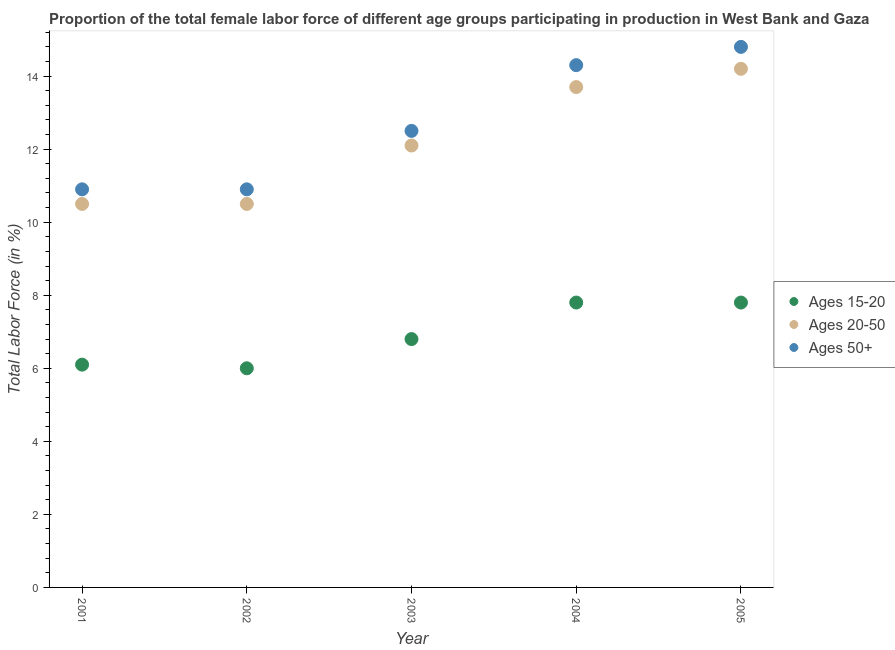How many different coloured dotlines are there?
Make the answer very short. 3. Is the number of dotlines equal to the number of legend labels?
Your answer should be very brief. Yes. What is the percentage of female labor force above age 50 in 2002?
Provide a short and direct response. 10.9. Across all years, what is the maximum percentage of female labor force within the age group 20-50?
Your response must be concise. 14.2. Across all years, what is the minimum percentage of female labor force within the age group 20-50?
Provide a short and direct response. 10.5. In which year was the percentage of female labor force within the age group 15-20 maximum?
Offer a very short reply. 2004. What is the total percentage of female labor force above age 50 in the graph?
Provide a succinct answer. 63.4. What is the difference between the percentage of female labor force within the age group 15-20 in 2002 and that in 2003?
Keep it short and to the point. -0.8. What is the difference between the percentage of female labor force within the age group 15-20 in 2005 and the percentage of female labor force above age 50 in 2004?
Give a very brief answer. -6.5. What is the average percentage of female labor force above age 50 per year?
Provide a succinct answer. 12.68. In the year 2001, what is the difference between the percentage of female labor force above age 50 and percentage of female labor force within the age group 20-50?
Your answer should be compact. 0.4. In how many years, is the percentage of female labor force above age 50 greater than 11.2 %?
Keep it short and to the point. 3. What is the ratio of the percentage of female labor force within the age group 20-50 in 2002 to that in 2005?
Provide a succinct answer. 0.74. What is the difference between the highest and the second highest percentage of female labor force above age 50?
Make the answer very short. 0.5. What is the difference between the highest and the lowest percentage of female labor force within the age group 20-50?
Provide a short and direct response. 3.7. Are the values on the major ticks of Y-axis written in scientific E-notation?
Make the answer very short. No. Does the graph contain any zero values?
Your answer should be very brief. No. Does the graph contain grids?
Ensure brevity in your answer.  No. How are the legend labels stacked?
Provide a short and direct response. Vertical. What is the title of the graph?
Provide a succinct answer. Proportion of the total female labor force of different age groups participating in production in West Bank and Gaza. What is the Total Labor Force (in %) in Ages 15-20 in 2001?
Make the answer very short. 6.1. What is the Total Labor Force (in %) of Ages 20-50 in 2001?
Your answer should be compact. 10.5. What is the Total Labor Force (in %) of Ages 50+ in 2001?
Your answer should be very brief. 10.9. What is the Total Labor Force (in %) of Ages 15-20 in 2002?
Offer a terse response. 6. What is the Total Labor Force (in %) of Ages 20-50 in 2002?
Offer a very short reply. 10.5. What is the Total Labor Force (in %) of Ages 50+ in 2002?
Offer a very short reply. 10.9. What is the Total Labor Force (in %) in Ages 15-20 in 2003?
Your answer should be very brief. 6.8. What is the Total Labor Force (in %) in Ages 20-50 in 2003?
Your answer should be very brief. 12.1. What is the Total Labor Force (in %) of Ages 15-20 in 2004?
Give a very brief answer. 7.8. What is the Total Labor Force (in %) of Ages 20-50 in 2004?
Your answer should be very brief. 13.7. What is the Total Labor Force (in %) of Ages 50+ in 2004?
Your answer should be compact. 14.3. What is the Total Labor Force (in %) of Ages 15-20 in 2005?
Provide a short and direct response. 7.8. What is the Total Labor Force (in %) of Ages 20-50 in 2005?
Provide a succinct answer. 14.2. What is the Total Labor Force (in %) of Ages 50+ in 2005?
Your response must be concise. 14.8. Across all years, what is the maximum Total Labor Force (in %) in Ages 15-20?
Provide a short and direct response. 7.8. Across all years, what is the maximum Total Labor Force (in %) of Ages 20-50?
Keep it short and to the point. 14.2. Across all years, what is the maximum Total Labor Force (in %) of Ages 50+?
Give a very brief answer. 14.8. Across all years, what is the minimum Total Labor Force (in %) in Ages 20-50?
Make the answer very short. 10.5. Across all years, what is the minimum Total Labor Force (in %) in Ages 50+?
Offer a terse response. 10.9. What is the total Total Labor Force (in %) of Ages 15-20 in the graph?
Your answer should be very brief. 34.5. What is the total Total Labor Force (in %) of Ages 20-50 in the graph?
Offer a very short reply. 61. What is the total Total Labor Force (in %) in Ages 50+ in the graph?
Offer a terse response. 63.4. What is the difference between the Total Labor Force (in %) of Ages 15-20 in 2001 and that in 2002?
Ensure brevity in your answer.  0.1. What is the difference between the Total Labor Force (in %) of Ages 20-50 in 2001 and that in 2002?
Make the answer very short. 0. What is the difference between the Total Labor Force (in %) in Ages 50+ in 2001 and that in 2002?
Your answer should be compact. 0. What is the difference between the Total Labor Force (in %) of Ages 15-20 in 2001 and that in 2004?
Your response must be concise. -1.7. What is the difference between the Total Labor Force (in %) of Ages 50+ in 2001 and that in 2004?
Your response must be concise. -3.4. What is the difference between the Total Labor Force (in %) of Ages 15-20 in 2001 and that in 2005?
Your answer should be very brief. -1.7. What is the difference between the Total Labor Force (in %) in Ages 20-50 in 2001 and that in 2005?
Offer a terse response. -3.7. What is the difference between the Total Labor Force (in %) of Ages 50+ in 2002 and that in 2003?
Provide a short and direct response. -1.6. What is the difference between the Total Labor Force (in %) of Ages 50+ in 2002 and that in 2005?
Your response must be concise. -3.9. What is the difference between the Total Labor Force (in %) of Ages 15-20 in 2003 and that in 2004?
Give a very brief answer. -1. What is the difference between the Total Labor Force (in %) in Ages 50+ in 2003 and that in 2004?
Ensure brevity in your answer.  -1.8. What is the difference between the Total Labor Force (in %) of Ages 15-20 in 2003 and that in 2005?
Give a very brief answer. -1. What is the difference between the Total Labor Force (in %) of Ages 20-50 in 2003 and that in 2005?
Make the answer very short. -2.1. What is the difference between the Total Labor Force (in %) in Ages 50+ in 2003 and that in 2005?
Your response must be concise. -2.3. What is the difference between the Total Labor Force (in %) of Ages 15-20 in 2004 and that in 2005?
Your answer should be very brief. 0. What is the difference between the Total Labor Force (in %) of Ages 20-50 in 2004 and that in 2005?
Make the answer very short. -0.5. What is the difference between the Total Labor Force (in %) in Ages 50+ in 2004 and that in 2005?
Your answer should be compact. -0.5. What is the difference between the Total Labor Force (in %) in Ages 15-20 in 2001 and the Total Labor Force (in %) in Ages 20-50 in 2003?
Make the answer very short. -6. What is the difference between the Total Labor Force (in %) of Ages 15-20 in 2001 and the Total Labor Force (in %) of Ages 50+ in 2003?
Make the answer very short. -6.4. What is the difference between the Total Labor Force (in %) of Ages 15-20 in 2001 and the Total Labor Force (in %) of Ages 20-50 in 2004?
Make the answer very short. -7.6. What is the difference between the Total Labor Force (in %) in Ages 15-20 in 2001 and the Total Labor Force (in %) in Ages 50+ in 2004?
Give a very brief answer. -8.2. What is the difference between the Total Labor Force (in %) of Ages 20-50 in 2001 and the Total Labor Force (in %) of Ages 50+ in 2004?
Ensure brevity in your answer.  -3.8. What is the difference between the Total Labor Force (in %) of Ages 15-20 in 2001 and the Total Labor Force (in %) of Ages 20-50 in 2005?
Your answer should be compact. -8.1. What is the difference between the Total Labor Force (in %) in Ages 15-20 in 2001 and the Total Labor Force (in %) in Ages 50+ in 2005?
Keep it short and to the point. -8.7. What is the difference between the Total Labor Force (in %) in Ages 15-20 in 2002 and the Total Labor Force (in %) in Ages 20-50 in 2004?
Ensure brevity in your answer.  -7.7. What is the difference between the Total Labor Force (in %) of Ages 15-20 in 2002 and the Total Labor Force (in %) of Ages 50+ in 2004?
Keep it short and to the point. -8.3. What is the difference between the Total Labor Force (in %) of Ages 20-50 in 2002 and the Total Labor Force (in %) of Ages 50+ in 2004?
Offer a very short reply. -3.8. What is the difference between the Total Labor Force (in %) of Ages 15-20 in 2002 and the Total Labor Force (in %) of Ages 20-50 in 2005?
Provide a succinct answer. -8.2. What is the difference between the Total Labor Force (in %) in Ages 15-20 in 2002 and the Total Labor Force (in %) in Ages 50+ in 2005?
Your answer should be compact. -8.8. What is the difference between the Total Labor Force (in %) in Ages 15-20 in 2003 and the Total Labor Force (in %) in Ages 50+ in 2005?
Your answer should be very brief. -8. What is the difference between the Total Labor Force (in %) of Ages 20-50 in 2003 and the Total Labor Force (in %) of Ages 50+ in 2005?
Make the answer very short. -2.7. What is the average Total Labor Force (in %) of Ages 15-20 per year?
Ensure brevity in your answer.  6.9. What is the average Total Labor Force (in %) in Ages 20-50 per year?
Provide a succinct answer. 12.2. What is the average Total Labor Force (in %) of Ages 50+ per year?
Give a very brief answer. 12.68. In the year 2001, what is the difference between the Total Labor Force (in %) in Ages 15-20 and Total Labor Force (in %) in Ages 20-50?
Provide a short and direct response. -4.4. In the year 2001, what is the difference between the Total Labor Force (in %) of Ages 15-20 and Total Labor Force (in %) of Ages 50+?
Offer a terse response. -4.8. In the year 2002, what is the difference between the Total Labor Force (in %) of Ages 15-20 and Total Labor Force (in %) of Ages 50+?
Your answer should be very brief. -4.9. In the year 2002, what is the difference between the Total Labor Force (in %) of Ages 20-50 and Total Labor Force (in %) of Ages 50+?
Keep it short and to the point. -0.4. In the year 2003, what is the difference between the Total Labor Force (in %) in Ages 15-20 and Total Labor Force (in %) in Ages 20-50?
Make the answer very short. -5.3. In the year 2003, what is the difference between the Total Labor Force (in %) of Ages 15-20 and Total Labor Force (in %) of Ages 50+?
Your answer should be compact. -5.7. In the year 2003, what is the difference between the Total Labor Force (in %) in Ages 20-50 and Total Labor Force (in %) in Ages 50+?
Provide a succinct answer. -0.4. In the year 2004, what is the difference between the Total Labor Force (in %) of Ages 20-50 and Total Labor Force (in %) of Ages 50+?
Your answer should be very brief. -0.6. In the year 2005, what is the difference between the Total Labor Force (in %) in Ages 15-20 and Total Labor Force (in %) in Ages 20-50?
Make the answer very short. -6.4. In the year 2005, what is the difference between the Total Labor Force (in %) in Ages 20-50 and Total Labor Force (in %) in Ages 50+?
Provide a short and direct response. -0.6. What is the ratio of the Total Labor Force (in %) in Ages 15-20 in 2001 to that in 2002?
Provide a short and direct response. 1.02. What is the ratio of the Total Labor Force (in %) in Ages 20-50 in 2001 to that in 2002?
Your answer should be compact. 1. What is the ratio of the Total Labor Force (in %) in Ages 50+ in 2001 to that in 2002?
Provide a short and direct response. 1. What is the ratio of the Total Labor Force (in %) of Ages 15-20 in 2001 to that in 2003?
Ensure brevity in your answer.  0.9. What is the ratio of the Total Labor Force (in %) of Ages 20-50 in 2001 to that in 2003?
Provide a short and direct response. 0.87. What is the ratio of the Total Labor Force (in %) of Ages 50+ in 2001 to that in 2003?
Offer a terse response. 0.87. What is the ratio of the Total Labor Force (in %) in Ages 15-20 in 2001 to that in 2004?
Ensure brevity in your answer.  0.78. What is the ratio of the Total Labor Force (in %) of Ages 20-50 in 2001 to that in 2004?
Provide a short and direct response. 0.77. What is the ratio of the Total Labor Force (in %) of Ages 50+ in 2001 to that in 2004?
Your response must be concise. 0.76. What is the ratio of the Total Labor Force (in %) in Ages 15-20 in 2001 to that in 2005?
Your answer should be compact. 0.78. What is the ratio of the Total Labor Force (in %) in Ages 20-50 in 2001 to that in 2005?
Provide a succinct answer. 0.74. What is the ratio of the Total Labor Force (in %) in Ages 50+ in 2001 to that in 2005?
Provide a succinct answer. 0.74. What is the ratio of the Total Labor Force (in %) in Ages 15-20 in 2002 to that in 2003?
Ensure brevity in your answer.  0.88. What is the ratio of the Total Labor Force (in %) in Ages 20-50 in 2002 to that in 2003?
Offer a very short reply. 0.87. What is the ratio of the Total Labor Force (in %) of Ages 50+ in 2002 to that in 2003?
Your response must be concise. 0.87. What is the ratio of the Total Labor Force (in %) in Ages 15-20 in 2002 to that in 2004?
Give a very brief answer. 0.77. What is the ratio of the Total Labor Force (in %) in Ages 20-50 in 2002 to that in 2004?
Your answer should be compact. 0.77. What is the ratio of the Total Labor Force (in %) in Ages 50+ in 2002 to that in 2004?
Provide a succinct answer. 0.76. What is the ratio of the Total Labor Force (in %) of Ages 15-20 in 2002 to that in 2005?
Offer a very short reply. 0.77. What is the ratio of the Total Labor Force (in %) of Ages 20-50 in 2002 to that in 2005?
Offer a terse response. 0.74. What is the ratio of the Total Labor Force (in %) in Ages 50+ in 2002 to that in 2005?
Offer a terse response. 0.74. What is the ratio of the Total Labor Force (in %) of Ages 15-20 in 2003 to that in 2004?
Ensure brevity in your answer.  0.87. What is the ratio of the Total Labor Force (in %) in Ages 20-50 in 2003 to that in 2004?
Offer a very short reply. 0.88. What is the ratio of the Total Labor Force (in %) of Ages 50+ in 2003 to that in 2004?
Ensure brevity in your answer.  0.87. What is the ratio of the Total Labor Force (in %) of Ages 15-20 in 2003 to that in 2005?
Your answer should be very brief. 0.87. What is the ratio of the Total Labor Force (in %) of Ages 20-50 in 2003 to that in 2005?
Provide a succinct answer. 0.85. What is the ratio of the Total Labor Force (in %) of Ages 50+ in 2003 to that in 2005?
Ensure brevity in your answer.  0.84. What is the ratio of the Total Labor Force (in %) in Ages 20-50 in 2004 to that in 2005?
Your answer should be compact. 0.96. What is the ratio of the Total Labor Force (in %) in Ages 50+ in 2004 to that in 2005?
Your response must be concise. 0.97. What is the difference between the highest and the second highest Total Labor Force (in %) of Ages 20-50?
Make the answer very short. 0.5. What is the difference between the highest and the lowest Total Labor Force (in %) of Ages 15-20?
Offer a terse response. 1.8. 